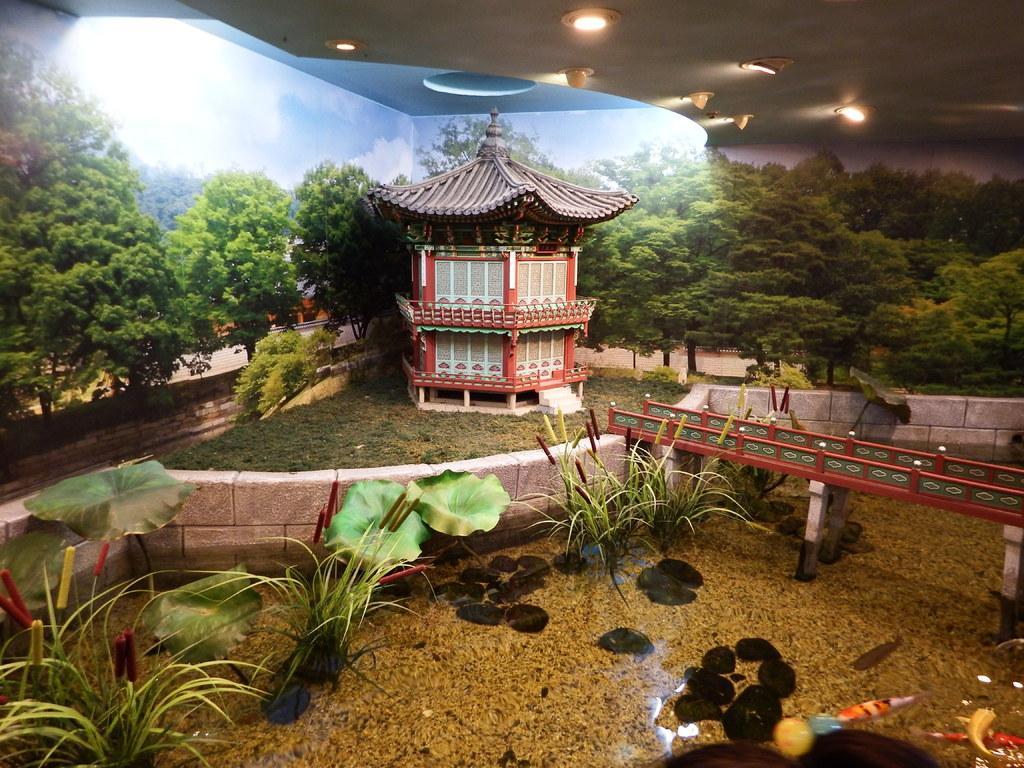Can you describe this image briefly? In this image we can see there is a poster. And there is a building, bridge, grass, trees, wall and water. In the water there are stones, fishes and plants. At the top there is a ceiling and lights. 